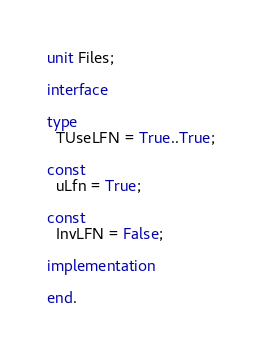<code> <loc_0><loc_0><loc_500><loc_500><_Pascal_>unit Files;

interface

type
  TUseLFN = True..True;

const
  uLfn = True;

const
  InvLFN = False;

implementation

end.
</code> 